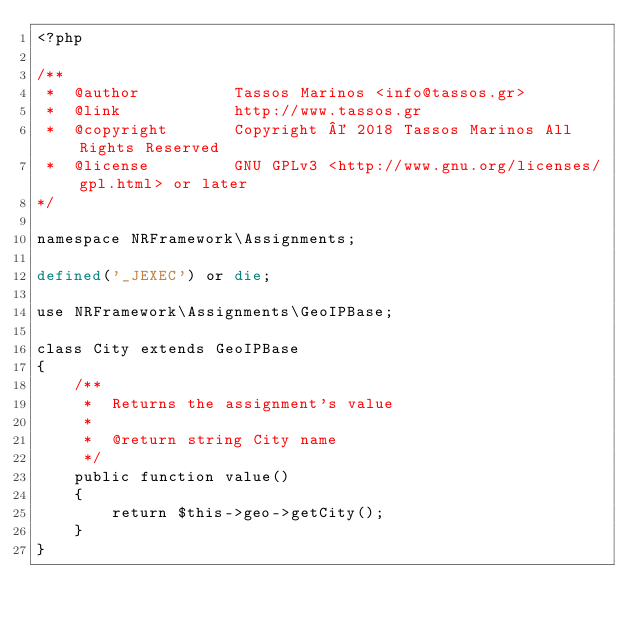Convert code to text. <code><loc_0><loc_0><loc_500><loc_500><_PHP_><?php

/**
 *  @author          Tassos Marinos <info@tassos.gr>
 *  @link            http://www.tassos.gr
 *  @copyright       Copyright © 2018 Tassos Marinos All Rights Reserved
 *  @license         GNU GPLv3 <http://www.gnu.org/licenses/gpl.html> or later
*/

namespace NRFramework\Assignments;

defined('_JEXEC') or die;

use NRFramework\Assignments\GeoIPBase;

class City extends GeoIPBase
{
    /**
     *  Returns the assignment's value
     * 
     *  @return string City name
     */
	public function value()
	{
		return $this->geo->getCity();
	}
}</code> 